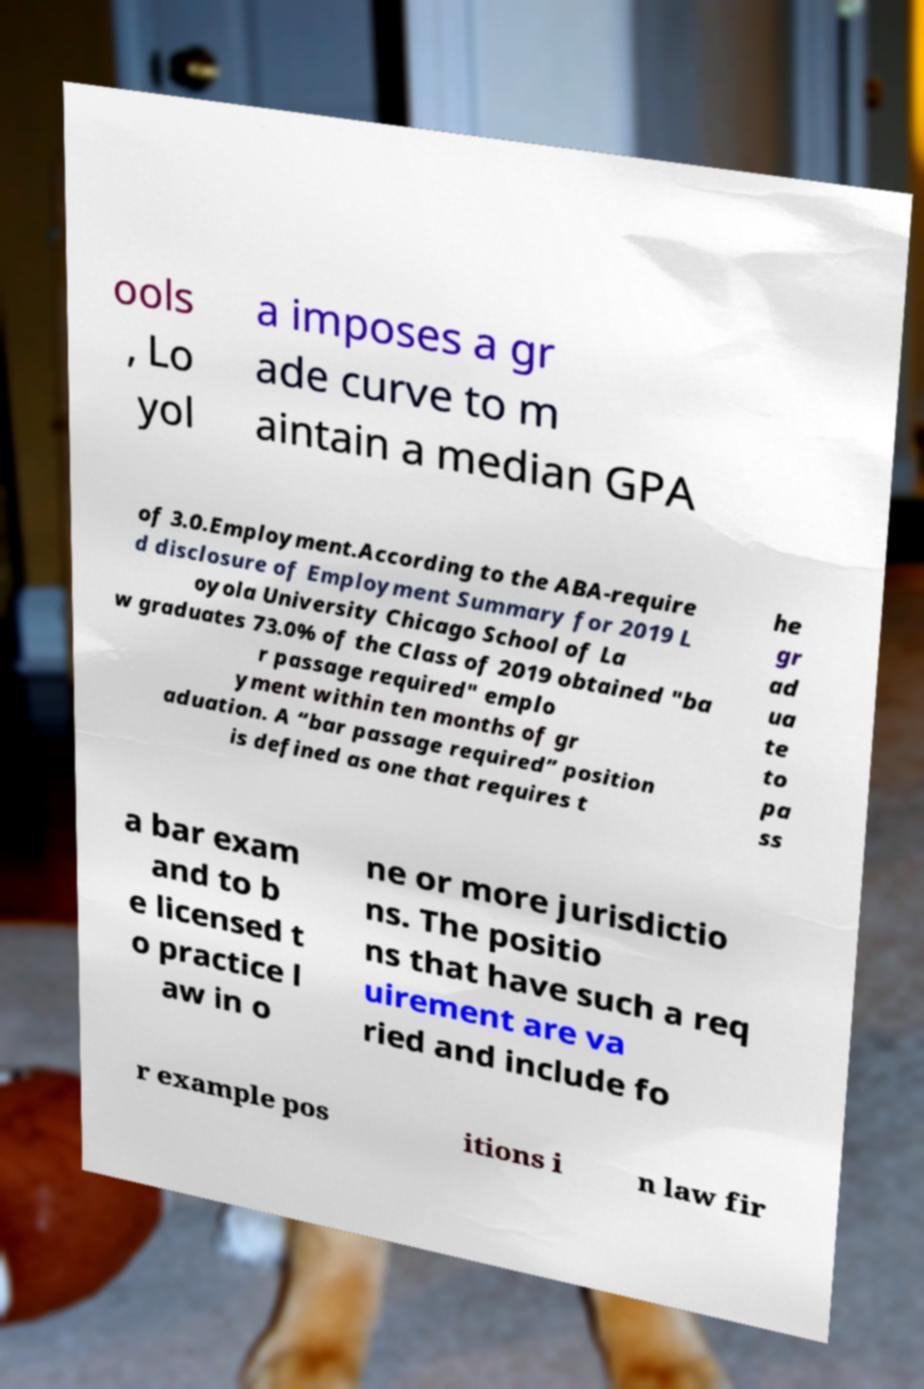I need the written content from this picture converted into text. Can you do that? ools , Lo yol a imposes a gr ade curve to m aintain a median GPA of 3.0.Employment.According to the ABA-require d disclosure of Employment Summary for 2019 L oyola University Chicago School of La w graduates 73.0% of the Class of 2019 obtained "ba r passage required" emplo yment within ten months of gr aduation. A “bar passage required” position is defined as one that requires t he gr ad ua te to pa ss a bar exam and to b e licensed t o practice l aw in o ne or more jurisdictio ns. The positio ns that have such a req uirement are va ried and include fo r example pos itions i n law fir 